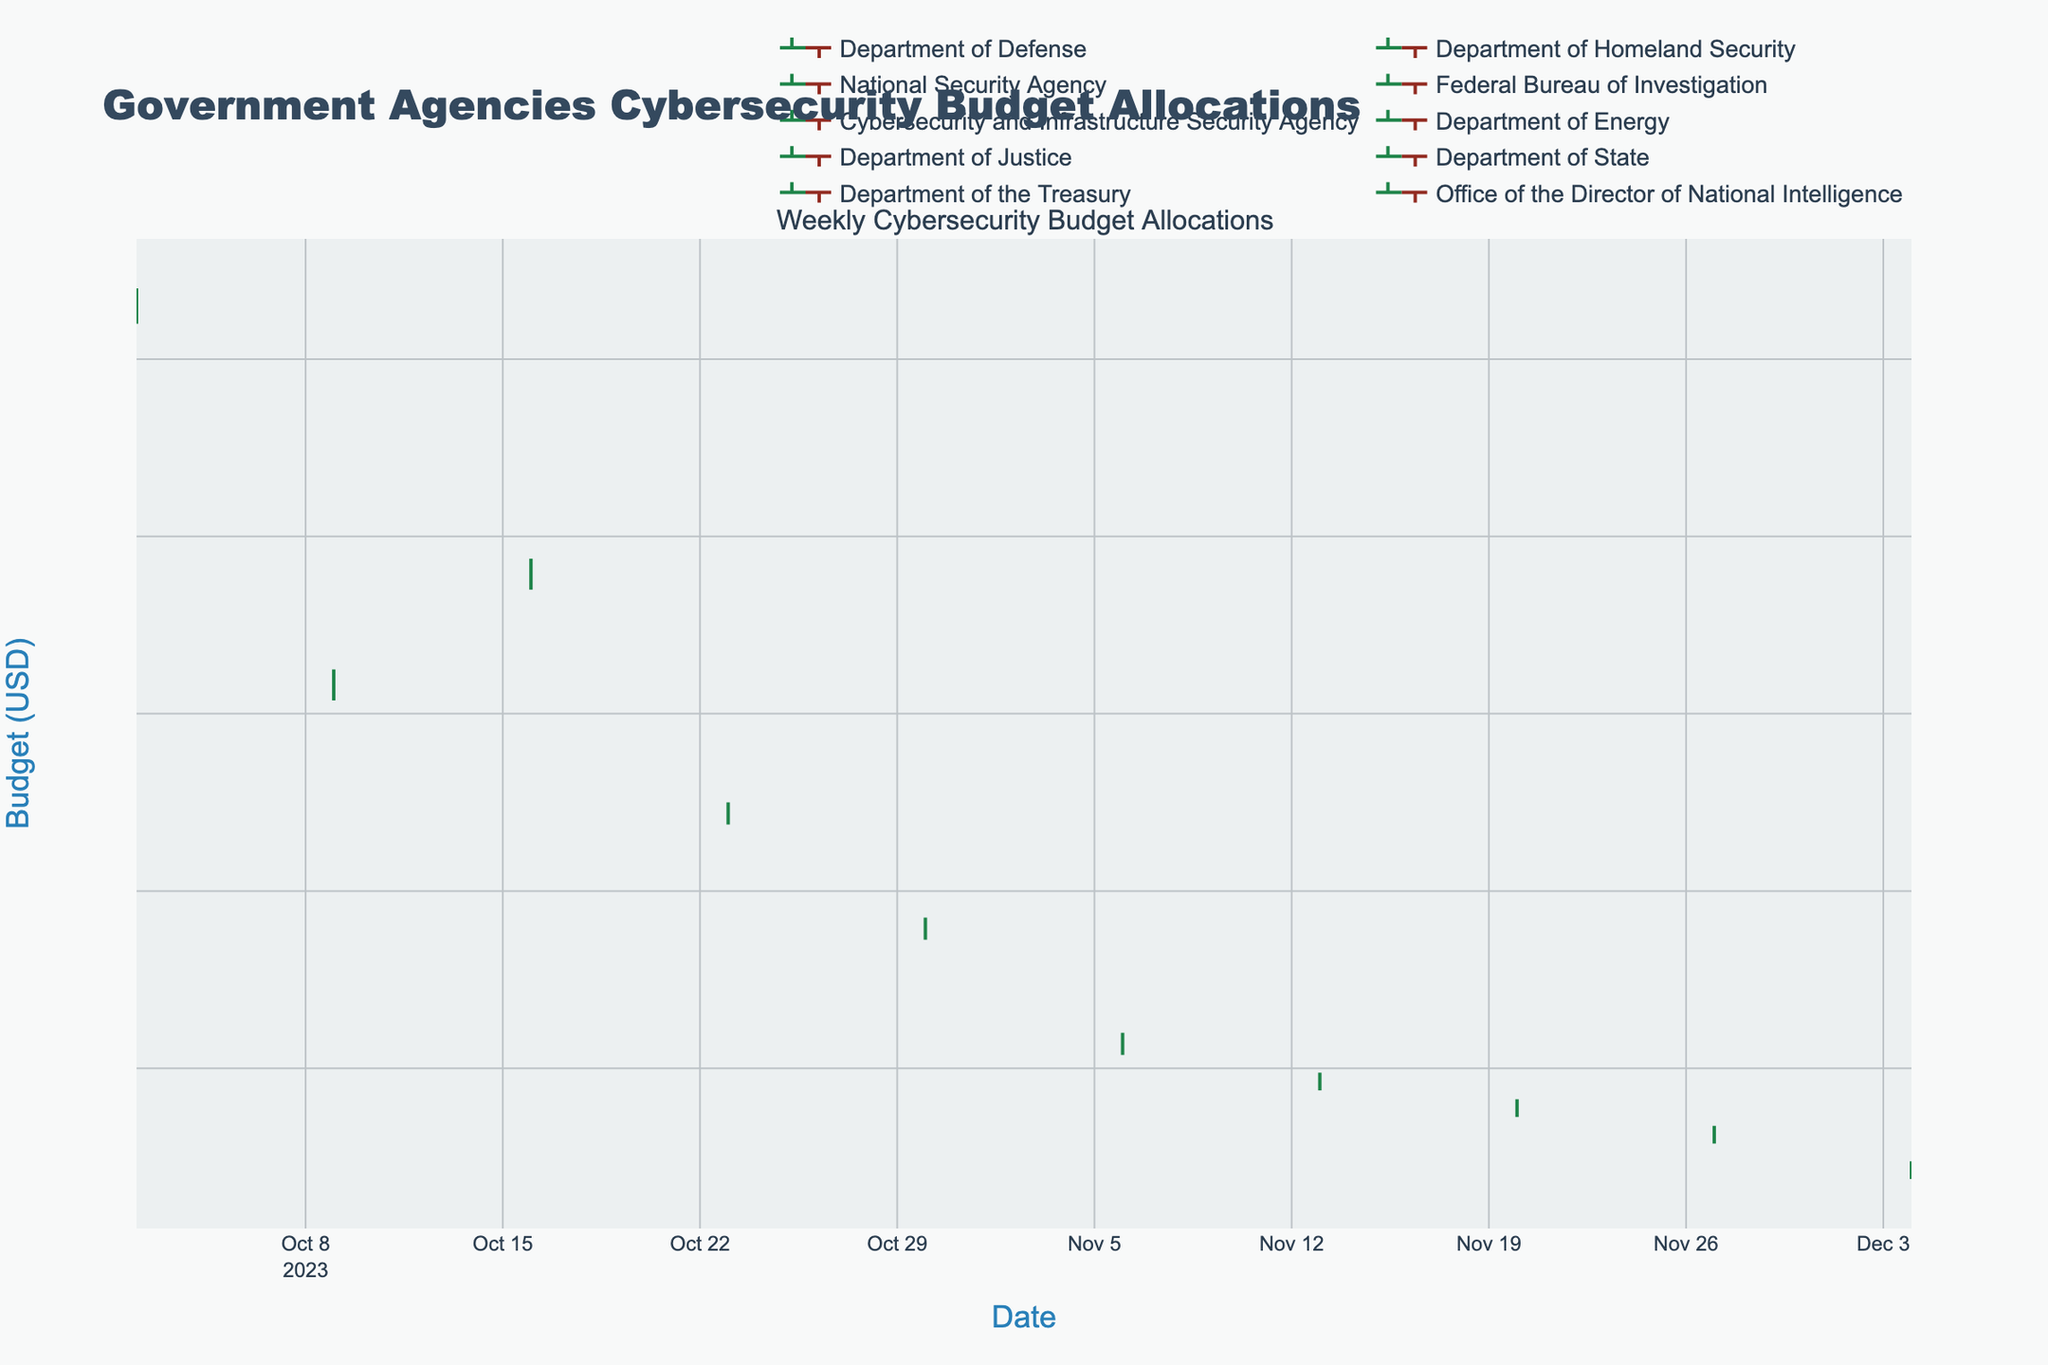What's the title of the figure? The title is prominently displayed at the top of the figure, usually in a larger font. Here, the title reads "Government Agencies Cybersecurity Budget Allocations."
Answer: Government Agencies Cybersecurity Budget Allocations What are the axes titles in the figure? The axes titles are found along the horizontal (x-axis) and vertical (y-axis) axes in the figure. The x-axis title is "Date," and the y-axis title is "Budget (USD)."
Answer: Date and Budget (USD) Which agency has the highest closing budget allocation in the last week of October 2023? By examining the OHLC bars for each agency within the date range corresponding to the last week of October, the Federal Bureau of Investigation has "69500000" as the closing budget allocation.
Answer: Federal Bureau of Investigation What pattern can be observed in the budget allocations of the Department of Defense over the given period? We see that the Department of Defense has only one data point, which shows a slight increase from "Open" (125000000) to "Close" (126500000) with minor fluctuations in "High" (128000000) and "Low" (124000000) within that week.
Answer: Slight increase with minor fluctuations How does the lowest budget allocation of the Department of Energy compare to the highest budget allocation of the Department of the Treasury? The Department of Energy’s lowest allocation is "41500000," and the Treasury's highest is "33500000." Comparing these, the Department of Energy's lowest budget allocation is still higher by "8000000."
Answer: 8000000 Which agency experienced the most stable budget allocation week according to the OHLC chart? Stability in budget allocation can be seen in an OHLC chart where the high and low values are close together. For example, the Office of the Director of National Intelligence's range from "High" (29500000) to "Low" (27500000), showing minimal fluctuation (2000000).
Answer: Office of the Director of National Intelligence On which week did the Cybersecurity and Infrastructure Security Agency have its closing budget value, and what was it? By looking at the OHLC chart, we observe that Cybersecurity and Infrastructure Security Agency has its values on the week of October 30th with a closing budget value of "56500000."
Answer: October 30th, 56500000 Which agency had the highest difference between its highest and lowest budget allocations in a given week? The difference between the high and low values indicates the range of allocations. The Department of Defense has the highest difference with "High" (128000000) minus "Low" (124000000), totaling "4000000."
Answer: Department of Defense Which week's data for the National Security Agency shows the highest closing budget and what is the respective value? On the week of October 16th, looking at the OHLC values, the closing value for the National Security Agency is "96000000," being the observed highest closing value on that week for the agency.
Answer: October 16th, 96000000 